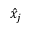Convert formula to latex. <formula><loc_0><loc_0><loc_500><loc_500>\hat { x } _ { j }</formula> 